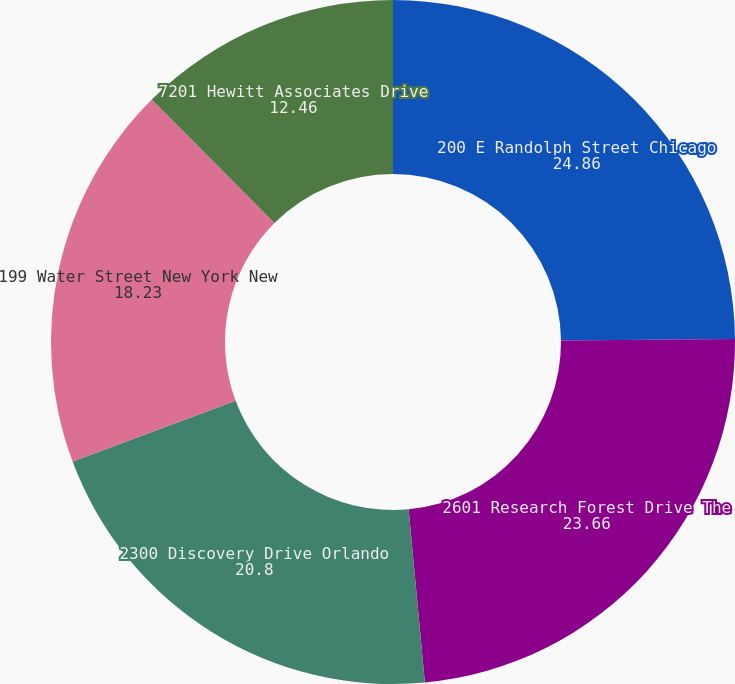Convert chart to OTSL. <chart><loc_0><loc_0><loc_500><loc_500><pie_chart><fcel>200 E Randolph Street Chicago<fcel>2601 Research Forest Drive The<fcel>2300 Discovery Drive Orlando<fcel>199 Water Street New York New<fcel>7201 Hewitt Associates Drive<nl><fcel>24.86%<fcel>23.66%<fcel>20.8%<fcel>18.23%<fcel>12.46%<nl></chart> 